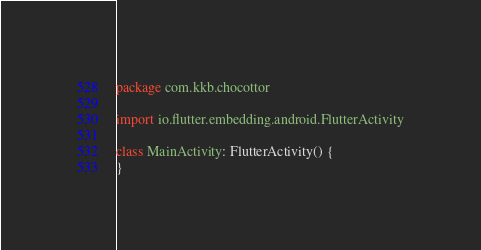Convert code to text. <code><loc_0><loc_0><loc_500><loc_500><_Kotlin_>package com.kkb.chocottor

import io.flutter.embedding.android.FlutterActivity

class MainActivity: FlutterActivity() {
}
</code> 